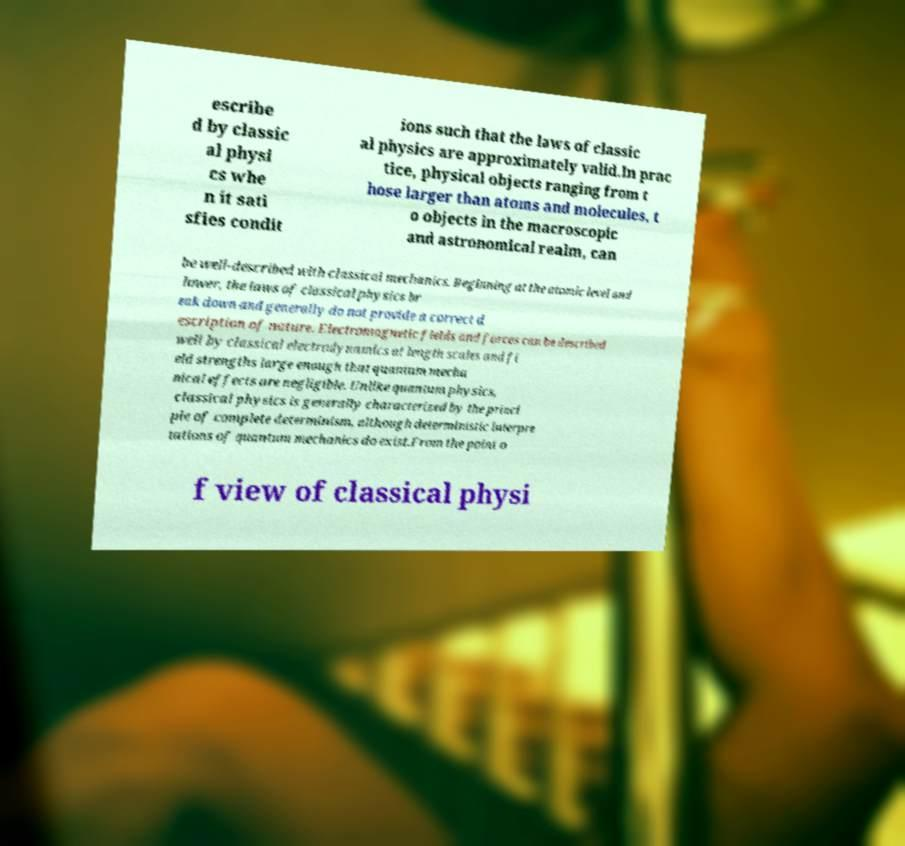Please read and relay the text visible in this image. What does it say? escribe d by classic al physi cs whe n it sati sfies condit ions such that the laws of classic al physics are approximately valid.In prac tice, physical objects ranging from t hose larger than atoms and molecules, t o objects in the macroscopic and astronomical realm, can be well-described with classical mechanics. Beginning at the atomic level and lower, the laws of classical physics br eak down and generally do not provide a correct d escription of nature. Electromagnetic fields and forces can be described well by classical electrodynamics at length scales and fi eld strengths large enough that quantum mecha nical effects are negligible. Unlike quantum physics, classical physics is generally characterized by the princi ple of complete determinism, although deterministic interpre tations of quantum mechanics do exist.From the point o f view of classical physi 